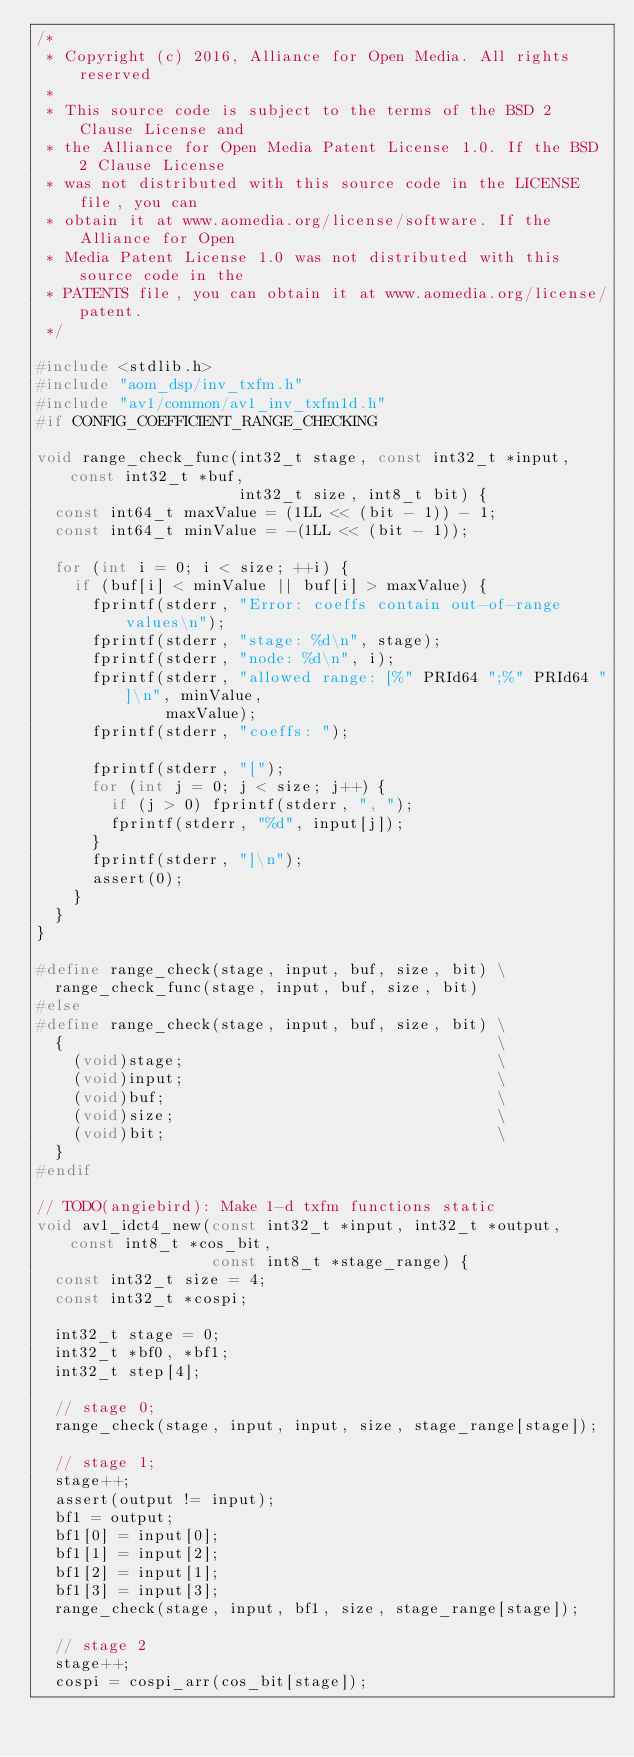Convert code to text. <code><loc_0><loc_0><loc_500><loc_500><_C_>/*
 * Copyright (c) 2016, Alliance for Open Media. All rights reserved
 *
 * This source code is subject to the terms of the BSD 2 Clause License and
 * the Alliance for Open Media Patent License 1.0. If the BSD 2 Clause License
 * was not distributed with this source code in the LICENSE file, you can
 * obtain it at www.aomedia.org/license/software. If the Alliance for Open
 * Media Patent License 1.0 was not distributed with this source code in the
 * PATENTS file, you can obtain it at www.aomedia.org/license/patent.
 */

#include <stdlib.h>
#include "aom_dsp/inv_txfm.h"
#include "av1/common/av1_inv_txfm1d.h"
#if CONFIG_COEFFICIENT_RANGE_CHECKING

void range_check_func(int32_t stage, const int32_t *input, const int32_t *buf,
                      int32_t size, int8_t bit) {
  const int64_t maxValue = (1LL << (bit - 1)) - 1;
  const int64_t minValue = -(1LL << (bit - 1));

  for (int i = 0; i < size; ++i) {
    if (buf[i] < minValue || buf[i] > maxValue) {
      fprintf(stderr, "Error: coeffs contain out-of-range values\n");
      fprintf(stderr, "stage: %d\n", stage);
      fprintf(stderr, "node: %d\n", i);
      fprintf(stderr, "allowed range: [%" PRId64 ";%" PRId64 "]\n", minValue,
              maxValue);
      fprintf(stderr, "coeffs: ");

      fprintf(stderr, "[");
      for (int j = 0; j < size; j++) {
        if (j > 0) fprintf(stderr, ", ");
        fprintf(stderr, "%d", input[j]);
      }
      fprintf(stderr, "]\n");
      assert(0);
    }
  }
}

#define range_check(stage, input, buf, size, bit) \
  range_check_func(stage, input, buf, size, bit)
#else
#define range_check(stage, input, buf, size, bit) \
  {                                               \
    (void)stage;                                  \
    (void)input;                                  \
    (void)buf;                                    \
    (void)size;                                   \
    (void)bit;                                    \
  }
#endif

// TODO(angiebird): Make 1-d txfm functions static
void av1_idct4_new(const int32_t *input, int32_t *output, const int8_t *cos_bit,
                   const int8_t *stage_range) {
  const int32_t size = 4;
  const int32_t *cospi;

  int32_t stage = 0;
  int32_t *bf0, *bf1;
  int32_t step[4];

  // stage 0;
  range_check(stage, input, input, size, stage_range[stage]);

  // stage 1;
  stage++;
  assert(output != input);
  bf1 = output;
  bf1[0] = input[0];
  bf1[1] = input[2];
  bf1[2] = input[1];
  bf1[3] = input[3];
  range_check(stage, input, bf1, size, stage_range[stage]);

  // stage 2
  stage++;
  cospi = cospi_arr(cos_bit[stage]);</code> 